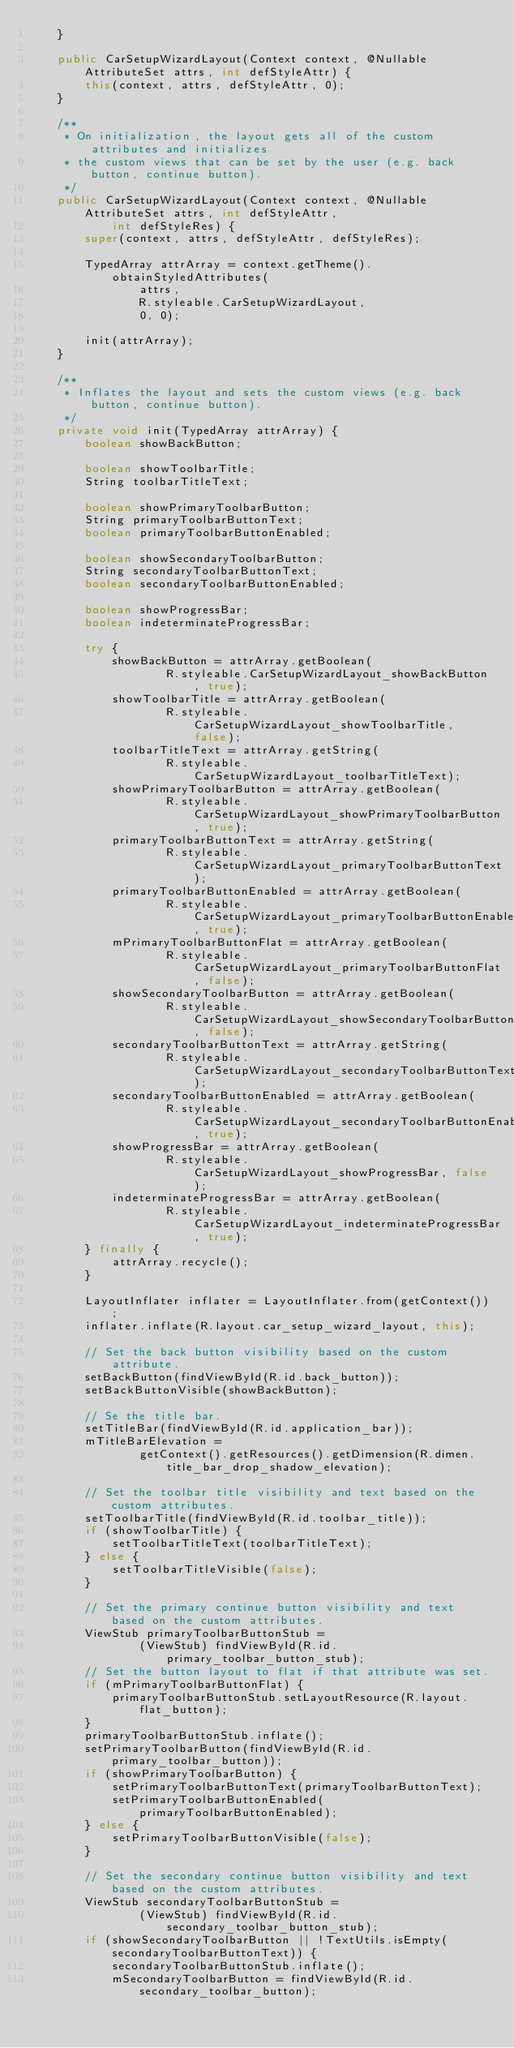Convert code to text. <code><loc_0><loc_0><loc_500><loc_500><_Java_>    }

    public CarSetupWizardLayout(Context context, @Nullable AttributeSet attrs, int defStyleAttr) {
        this(context, attrs, defStyleAttr, 0);
    }

    /**
     * On initialization, the layout gets all of the custom attributes and initializes
     * the custom views that can be set by the user (e.g. back button, continue button).
     */
    public CarSetupWizardLayout(Context context, @Nullable AttributeSet attrs, int defStyleAttr,
            int defStyleRes) {
        super(context, attrs, defStyleAttr, defStyleRes);

        TypedArray attrArray = context.getTheme().obtainStyledAttributes(
                attrs,
                R.styleable.CarSetupWizardLayout,
                0, 0);

        init(attrArray);
    }

    /**
     * Inflates the layout and sets the custom views (e.g. back button, continue button).
     */
    private void init(TypedArray attrArray) {
        boolean showBackButton;

        boolean showToolbarTitle;
        String toolbarTitleText;

        boolean showPrimaryToolbarButton;
        String primaryToolbarButtonText;
        boolean primaryToolbarButtonEnabled;

        boolean showSecondaryToolbarButton;
        String secondaryToolbarButtonText;
        boolean secondaryToolbarButtonEnabled;

        boolean showProgressBar;
        boolean indeterminateProgressBar;

        try {
            showBackButton = attrArray.getBoolean(
                    R.styleable.CarSetupWizardLayout_showBackButton, true);
            showToolbarTitle = attrArray.getBoolean(
                    R.styleable.CarSetupWizardLayout_showToolbarTitle, false);
            toolbarTitleText = attrArray.getString(
                    R.styleable.CarSetupWizardLayout_toolbarTitleText);
            showPrimaryToolbarButton = attrArray.getBoolean(
                    R.styleable.CarSetupWizardLayout_showPrimaryToolbarButton, true);
            primaryToolbarButtonText = attrArray.getString(
                    R.styleable.CarSetupWizardLayout_primaryToolbarButtonText);
            primaryToolbarButtonEnabled = attrArray.getBoolean(
                    R.styleable.CarSetupWizardLayout_primaryToolbarButtonEnabled, true);
            mPrimaryToolbarButtonFlat = attrArray.getBoolean(
                    R.styleable.CarSetupWizardLayout_primaryToolbarButtonFlat, false);
            showSecondaryToolbarButton = attrArray.getBoolean(
                    R.styleable.CarSetupWizardLayout_showSecondaryToolbarButton, false);
            secondaryToolbarButtonText = attrArray.getString(
                    R.styleable.CarSetupWizardLayout_secondaryToolbarButtonText);
            secondaryToolbarButtonEnabled = attrArray.getBoolean(
                    R.styleable.CarSetupWizardLayout_secondaryToolbarButtonEnabled, true);
            showProgressBar = attrArray.getBoolean(
                    R.styleable.CarSetupWizardLayout_showProgressBar, false);
            indeterminateProgressBar = attrArray.getBoolean(
                    R.styleable.CarSetupWizardLayout_indeterminateProgressBar, true);
        } finally {
            attrArray.recycle();
        }

        LayoutInflater inflater = LayoutInflater.from(getContext());
        inflater.inflate(R.layout.car_setup_wizard_layout, this);

        // Set the back button visibility based on the custom attribute.
        setBackButton(findViewById(R.id.back_button));
        setBackButtonVisible(showBackButton);

        // Se the title bar.
        setTitleBar(findViewById(R.id.application_bar));
        mTitleBarElevation =
                getContext().getResources().getDimension(R.dimen.title_bar_drop_shadow_elevation);

        // Set the toolbar title visibility and text based on the custom attributes.
        setToolbarTitle(findViewById(R.id.toolbar_title));
        if (showToolbarTitle) {
            setToolbarTitleText(toolbarTitleText);
        } else {
            setToolbarTitleVisible(false);
        }

        // Set the primary continue button visibility and text based on the custom attributes.
        ViewStub primaryToolbarButtonStub =
                (ViewStub) findViewById(R.id.primary_toolbar_button_stub);
        // Set the button layout to flat if that attribute was set.
        if (mPrimaryToolbarButtonFlat) {
            primaryToolbarButtonStub.setLayoutResource(R.layout.flat_button);
        }
        primaryToolbarButtonStub.inflate();
        setPrimaryToolbarButton(findViewById(R.id.primary_toolbar_button));
        if (showPrimaryToolbarButton) {
            setPrimaryToolbarButtonText(primaryToolbarButtonText);
            setPrimaryToolbarButtonEnabled(primaryToolbarButtonEnabled);
        } else {
            setPrimaryToolbarButtonVisible(false);
        }

        // Set the secondary continue button visibility and text based on the custom attributes.
        ViewStub secondaryToolbarButtonStub =
                (ViewStub) findViewById(R.id.secondary_toolbar_button_stub);
        if (showSecondaryToolbarButton || !TextUtils.isEmpty(secondaryToolbarButtonText)) {
            secondaryToolbarButtonStub.inflate();
            mSecondaryToolbarButton = findViewById(R.id.secondary_toolbar_button);</code> 